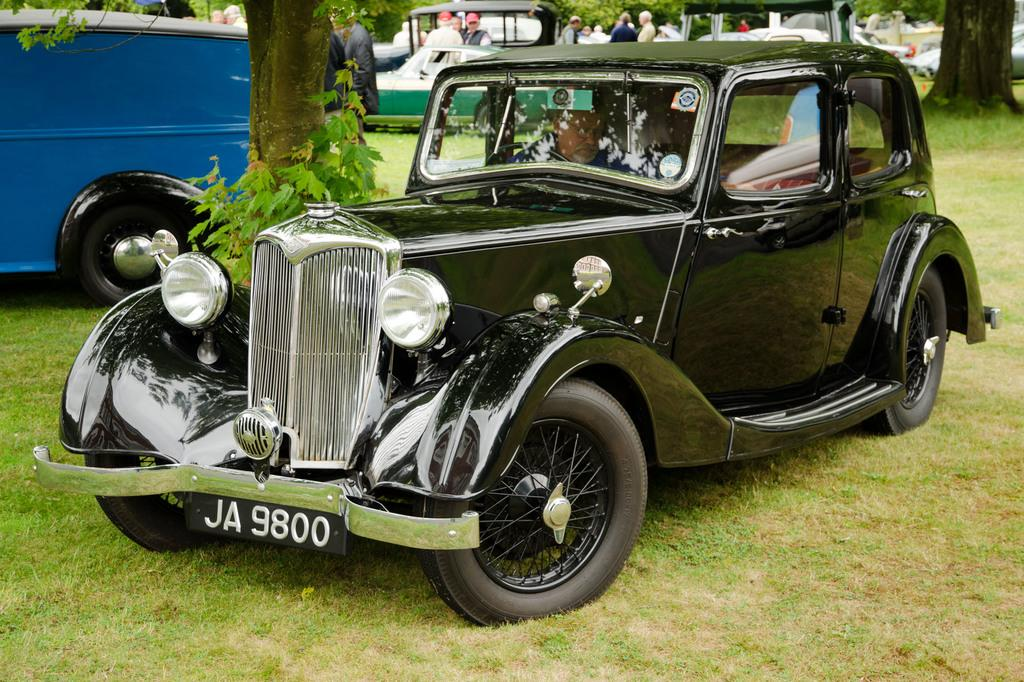What is the location of the vehicles in the image? The vehicles are on the grass in the image. Can you identify any other subjects in the image besides the vehicles? Yes, there are people and trees visible in the image. What type of appliance can be seen in the mouth of the person in the image? There is no appliance visible in the mouth of any person in the image. What type of picture is being taken in the image? The provided facts do not mention any picture being taken in the image. 